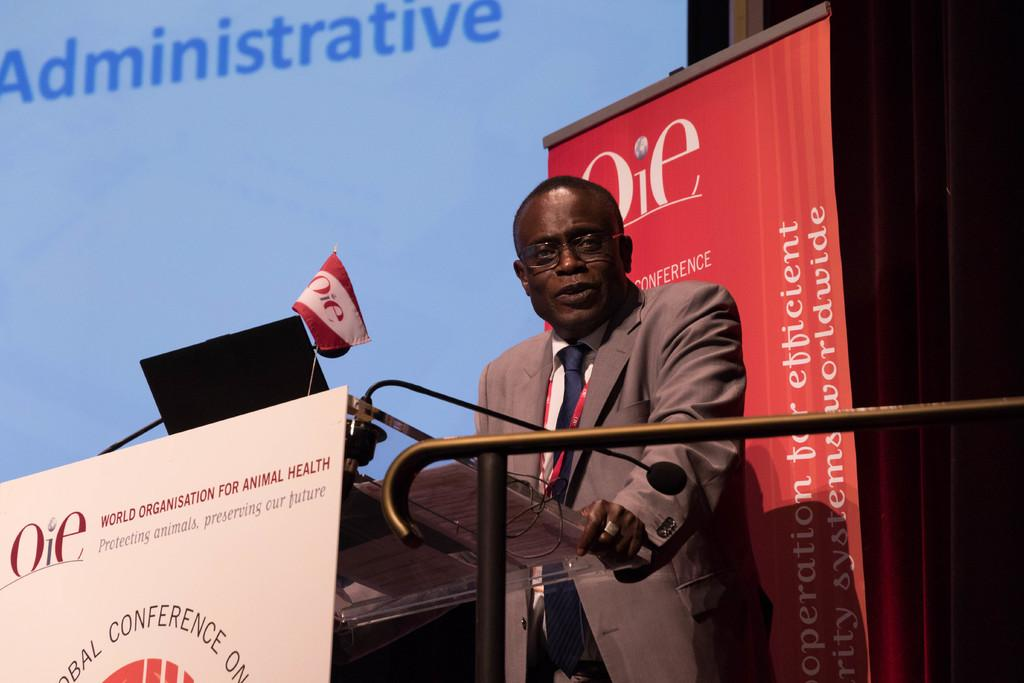What is the person in the image doing? The person is standing in front of the podium. What electronic device is visible in the image? There is a laptop in the image. What surface can be used for writing or displaying information? There is a board in the image. What type of signage is present in the image? There is a banner in the image. What national symbol is visible in the image? There is a flag in the image. What can be used for displaying visual content? There is a screen in the image. How many nuts are being used to hold the system together in the image? There are no nuts or systems present in the image; it features a person standing in front of a podium with various objects around them. How many feet are visible in the image? The number of feet visible in the image cannot be determined, as the person's feet are not shown. 